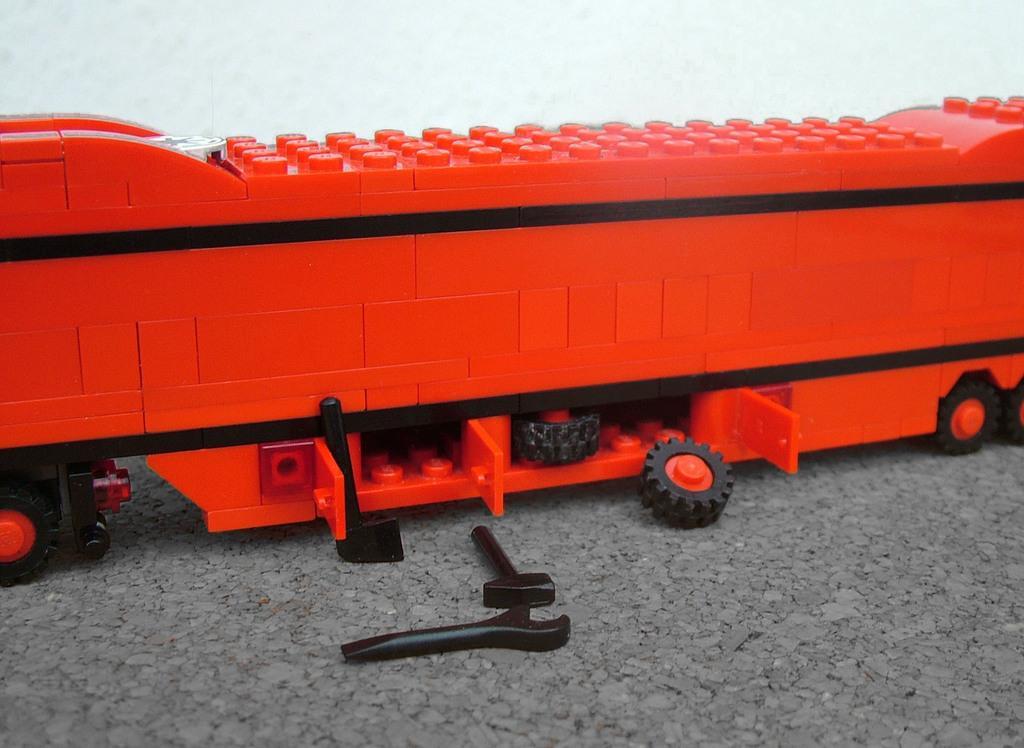Could you give a brief overview of what you see in this image? In this image there is a vehicle toy on the floor having some tool toys and tires on it. Background there is wall. 